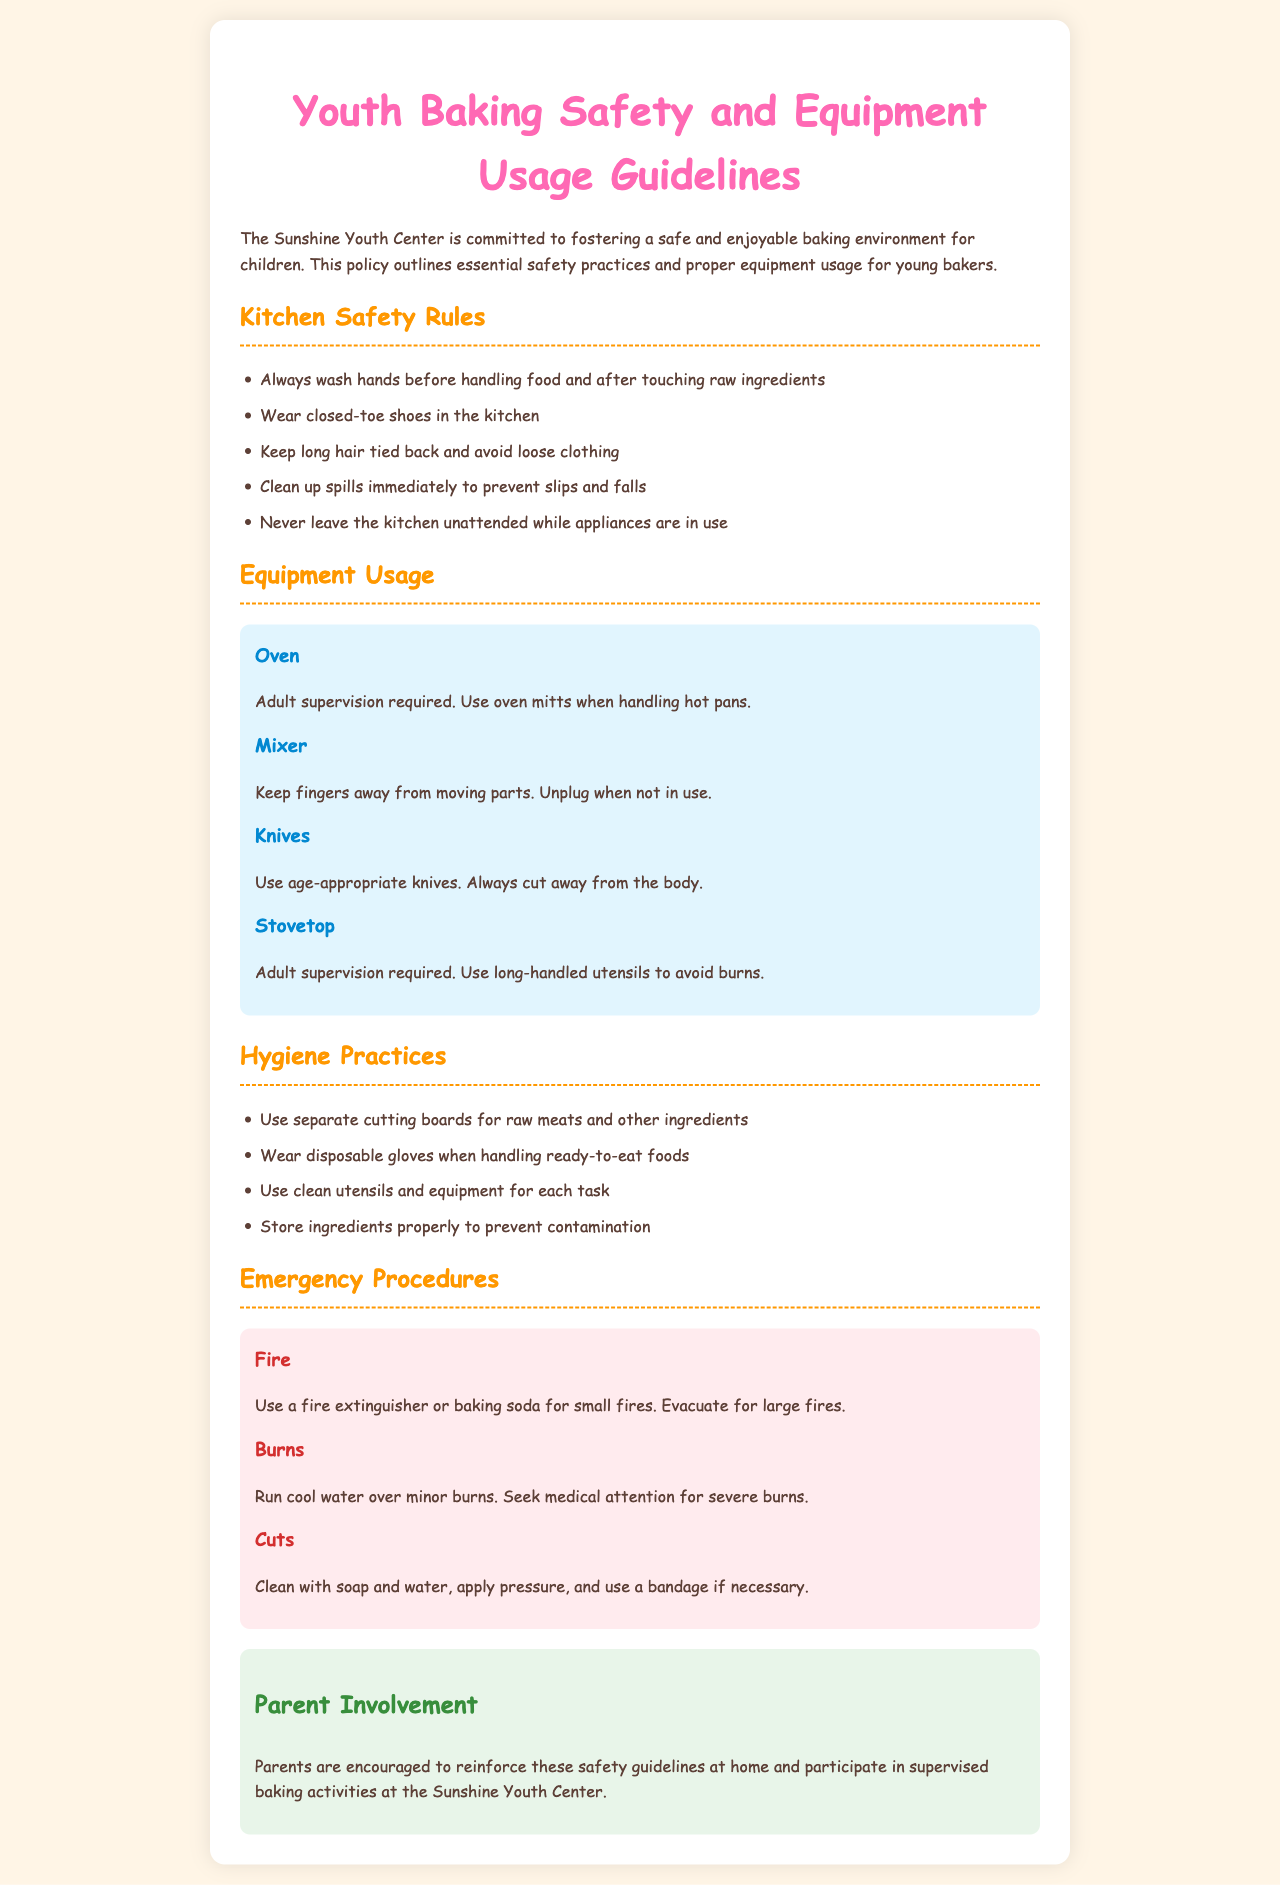What are the kitchen safety rules? The kitchen safety rules are listed in a bullet point format and cover essential safety practices young bakers should follow.
Answer: Always wash hands before handling food and after touching raw ingredients, wear closed-toe shoes, keep long hair tied back, clean up spills immediately, never leave the kitchen unattended while appliances are in use What should you do if you have a minor burn? The document provides guidance on handling burns, specifically addressing the treatment of minor burns.
Answer: Run cool water over minor burns What equipment requires adult supervision? The document specifies which equipment necessitates adult supervision for safety.
Answer: Oven, Stovetop What type of gloves should be worn when handling ready-to-eat foods? The hygiene practices section mentions the type of gloves to be used when dealing with certain foods.
Answer: Disposable gloves What should be done to prevent slips and falls in the kitchen? The safety rules involve actions that help mitigate risks associated with spills.
Answer: Clean up spills immediately What is the purpose of the parent involvement section? The document explains the role of parents concerning the safety guidelines.
Answer: Encourage reinforcement of safety guidelines at home and participation in supervised baking activities 